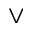<formula> <loc_0><loc_0><loc_500><loc_500>\vee</formula> 